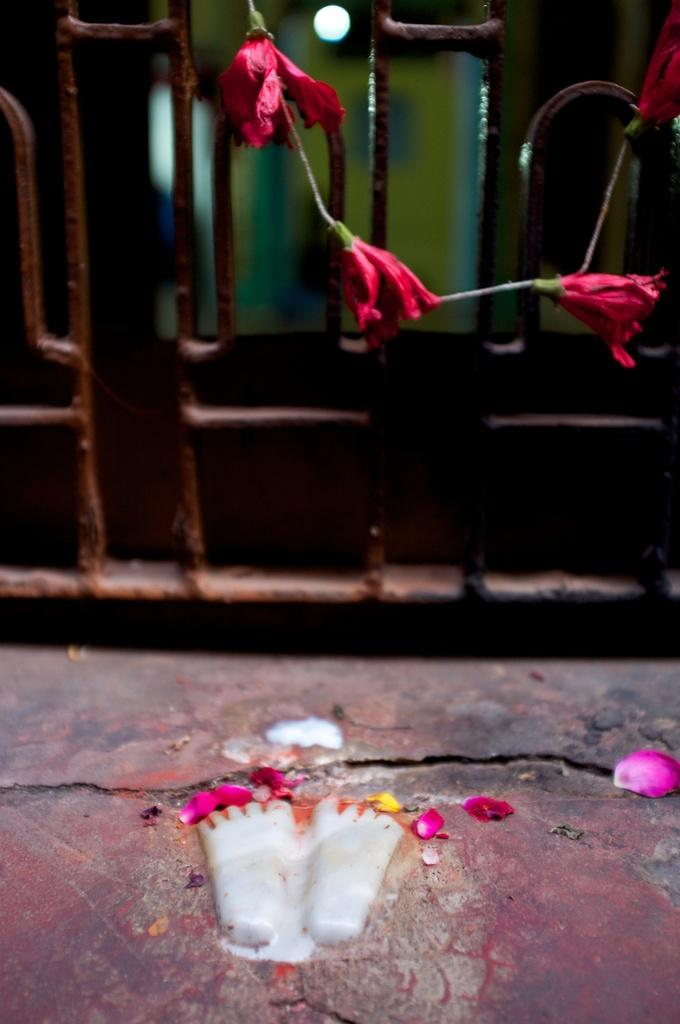What can be seen at the bottom of the image? There is a footprint of a person in the image. Where is the footprint located in relation to the rest of the image? The footprint is at the bottom of the image. What can be seen in the background of the image? There is a mesh in the background of the image. What date is circled on the calendar in the image? There is no calendar present in the image, so it is not possible to answer that question. 